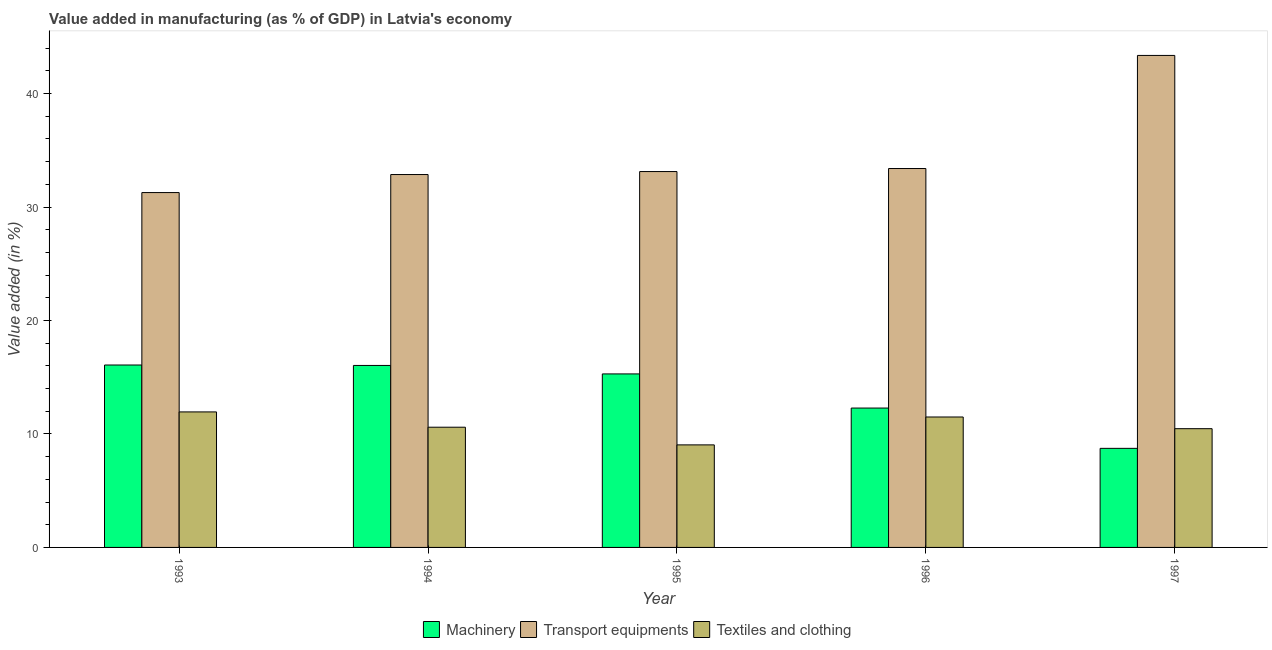How many different coloured bars are there?
Provide a short and direct response. 3. What is the value added in manufacturing textile and clothing in 1996?
Your answer should be compact. 11.5. Across all years, what is the maximum value added in manufacturing machinery?
Offer a terse response. 16.08. Across all years, what is the minimum value added in manufacturing textile and clothing?
Keep it short and to the point. 9.04. What is the total value added in manufacturing machinery in the graph?
Offer a very short reply. 68.42. What is the difference between the value added in manufacturing machinery in 1996 and that in 1997?
Offer a very short reply. 3.55. What is the difference between the value added in manufacturing transport equipments in 1997 and the value added in manufacturing machinery in 1994?
Keep it short and to the point. 10.5. What is the average value added in manufacturing textile and clothing per year?
Make the answer very short. 10.71. In the year 1993, what is the difference between the value added in manufacturing transport equipments and value added in manufacturing machinery?
Offer a very short reply. 0. What is the ratio of the value added in manufacturing transport equipments in 1994 to that in 1995?
Your answer should be very brief. 0.99. Is the difference between the value added in manufacturing machinery in 1995 and 1996 greater than the difference between the value added in manufacturing transport equipments in 1995 and 1996?
Make the answer very short. No. What is the difference between the highest and the second highest value added in manufacturing machinery?
Ensure brevity in your answer.  0.04. What is the difference between the highest and the lowest value added in manufacturing textile and clothing?
Provide a short and direct response. 2.91. In how many years, is the value added in manufacturing transport equipments greater than the average value added in manufacturing transport equipments taken over all years?
Your response must be concise. 1. Is the sum of the value added in manufacturing transport equipments in 1993 and 1994 greater than the maximum value added in manufacturing textile and clothing across all years?
Your answer should be very brief. Yes. What does the 3rd bar from the left in 1996 represents?
Ensure brevity in your answer.  Textiles and clothing. What does the 3rd bar from the right in 1993 represents?
Ensure brevity in your answer.  Machinery. Is it the case that in every year, the sum of the value added in manufacturing machinery and value added in manufacturing transport equipments is greater than the value added in manufacturing textile and clothing?
Make the answer very short. Yes. How many years are there in the graph?
Offer a very short reply. 5. Are the values on the major ticks of Y-axis written in scientific E-notation?
Make the answer very short. No. Does the graph contain any zero values?
Provide a short and direct response. No. Where does the legend appear in the graph?
Give a very brief answer. Bottom center. How are the legend labels stacked?
Ensure brevity in your answer.  Horizontal. What is the title of the graph?
Offer a very short reply. Value added in manufacturing (as % of GDP) in Latvia's economy. What is the label or title of the Y-axis?
Provide a succinct answer. Value added (in %). What is the Value added (in %) in Machinery in 1993?
Give a very brief answer. 16.08. What is the Value added (in %) in Transport equipments in 1993?
Ensure brevity in your answer.  31.28. What is the Value added (in %) in Textiles and clothing in 1993?
Your response must be concise. 11.94. What is the Value added (in %) of Machinery in 1994?
Your response must be concise. 16.04. What is the Value added (in %) of Transport equipments in 1994?
Keep it short and to the point. 32.86. What is the Value added (in %) of Textiles and clothing in 1994?
Your answer should be compact. 10.59. What is the Value added (in %) of Machinery in 1995?
Give a very brief answer. 15.29. What is the Value added (in %) in Transport equipments in 1995?
Your answer should be compact. 33.13. What is the Value added (in %) in Textiles and clothing in 1995?
Offer a very short reply. 9.04. What is the Value added (in %) in Machinery in 1996?
Provide a short and direct response. 12.28. What is the Value added (in %) in Transport equipments in 1996?
Provide a short and direct response. 33.39. What is the Value added (in %) of Textiles and clothing in 1996?
Your response must be concise. 11.5. What is the Value added (in %) in Machinery in 1997?
Make the answer very short. 8.73. What is the Value added (in %) in Transport equipments in 1997?
Keep it short and to the point. 43.36. What is the Value added (in %) of Textiles and clothing in 1997?
Make the answer very short. 10.47. Across all years, what is the maximum Value added (in %) in Machinery?
Provide a short and direct response. 16.08. Across all years, what is the maximum Value added (in %) in Transport equipments?
Your response must be concise. 43.36. Across all years, what is the maximum Value added (in %) of Textiles and clothing?
Your answer should be compact. 11.94. Across all years, what is the minimum Value added (in %) in Machinery?
Make the answer very short. 8.73. Across all years, what is the minimum Value added (in %) in Transport equipments?
Ensure brevity in your answer.  31.28. Across all years, what is the minimum Value added (in %) in Textiles and clothing?
Your response must be concise. 9.04. What is the total Value added (in %) in Machinery in the graph?
Offer a terse response. 68.42. What is the total Value added (in %) in Transport equipments in the graph?
Offer a very short reply. 174.02. What is the total Value added (in %) in Textiles and clothing in the graph?
Provide a short and direct response. 53.54. What is the difference between the Value added (in %) in Machinery in 1993 and that in 1994?
Make the answer very short. 0.04. What is the difference between the Value added (in %) in Transport equipments in 1993 and that in 1994?
Offer a very short reply. -1.59. What is the difference between the Value added (in %) in Textiles and clothing in 1993 and that in 1994?
Offer a terse response. 1.35. What is the difference between the Value added (in %) of Machinery in 1993 and that in 1995?
Provide a succinct answer. 0.78. What is the difference between the Value added (in %) in Transport equipments in 1993 and that in 1995?
Your answer should be compact. -1.85. What is the difference between the Value added (in %) of Textiles and clothing in 1993 and that in 1995?
Provide a succinct answer. 2.91. What is the difference between the Value added (in %) in Machinery in 1993 and that in 1996?
Offer a terse response. 3.79. What is the difference between the Value added (in %) in Transport equipments in 1993 and that in 1996?
Your answer should be very brief. -2.12. What is the difference between the Value added (in %) of Textiles and clothing in 1993 and that in 1996?
Offer a very short reply. 0.45. What is the difference between the Value added (in %) in Machinery in 1993 and that in 1997?
Provide a succinct answer. 7.34. What is the difference between the Value added (in %) of Transport equipments in 1993 and that in 1997?
Ensure brevity in your answer.  -12.09. What is the difference between the Value added (in %) in Textiles and clothing in 1993 and that in 1997?
Give a very brief answer. 1.48. What is the difference between the Value added (in %) of Machinery in 1994 and that in 1995?
Make the answer very short. 0.75. What is the difference between the Value added (in %) of Transport equipments in 1994 and that in 1995?
Keep it short and to the point. -0.26. What is the difference between the Value added (in %) of Textiles and clothing in 1994 and that in 1995?
Your response must be concise. 1.56. What is the difference between the Value added (in %) of Machinery in 1994 and that in 1996?
Your response must be concise. 3.76. What is the difference between the Value added (in %) in Transport equipments in 1994 and that in 1996?
Offer a very short reply. -0.53. What is the difference between the Value added (in %) in Textiles and clothing in 1994 and that in 1996?
Your answer should be compact. -0.9. What is the difference between the Value added (in %) of Machinery in 1994 and that in 1997?
Offer a terse response. 7.31. What is the difference between the Value added (in %) in Transport equipments in 1994 and that in 1997?
Make the answer very short. -10.5. What is the difference between the Value added (in %) in Textiles and clothing in 1994 and that in 1997?
Provide a short and direct response. 0.13. What is the difference between the Value added (in %) of Machinery in 1995 and that in 1996?
Give a very brief answer. 3.01. What is the difference between the Value added (in %) in Transport equipments in 1995 and that in 1996?
Ensure brevity in your answer.  -0.27. What is the difference between the Value added (in %) in Textiles and clothing in 1995 and that in 1996?
Provide a succinct answer. -2.46. What is the difference between the Value added (in %) of Machinery in 1995 and that in 1997?
Offer a very short reply. 6.56. What is the difference between the Value added (in %) of Transport equipments in 1995 and that in 1997?
Offer a very short reply. -10.23. What is the difference between the Value added (in %) in Textiles and clothing in 1995 and that in 1997?
Provide a succinct answer. -1.43. What is the difference between the Value added (in %) in Machinery in 1996 and that in 1997?
Your answer should be compact. 3.55. What is the difference between the Value added (in %) of Transport equipments in 1996 and that in 1997?
Make the answer very short. -9.97. What is the difference between the Value added (in %) in Textiles and clothing in 1996 and that in 1997?
Your answer should be very brief. 1.03. What is the difference between the Value added (in %) of Machinery in 1993 and the Value added (in %) of Transport equipments in 1994?
Your answer should be very brief. -16.79. What is the difference between the Value added (in %) of Machinery in 1993 and the Value added (in %) of Textiles and clothing in 1994?
Make the answer very short. 5.48. What is the difference between the Value added (in %) in Transport equipments in 1993 and the Value added (in %) in Textiles and clothing in 1994?
Your answer should be compact. 20.68. What is the difference between the Value added (in %) of Machinery in 1993 and the Value added (in %) of Transport equipments in 1995?
Provide a succinct answer. -17.05. What is the difference between the Value added (in %) in Machinery in 1993 and the Value added (in %) in Textiles and clothing in 1995?
Keep it short and to the point. 7.04. What is the difference between the Value added (in %) in Transport equipments in 1993 and the Value added (in %) in Textiles and clothing in 1995?
Make the answer very short. 22.24. What is the difference between the Value added (in %) of Machinery in 1993 and the Value added (in %) of Transport equipments in 1996?
Give a very brief answer. -17.32. What is the difference between the Value added (in %) in Machinery in 1993 and the Value added (in %) in Textiles and clothing in 1996?
Your answer should be compact. 4.58. What is the difference between the Value added (in %) in Transport equipments in 1993 and the Value added (in %) in Textiles and clothing in 1996?
Your answer should be very brief. 19.78. What is the difference between the Value added (in %) in Machinery in 1993 and the Value added (in %) in Transport equipments in 1997?
Your response must be concise. -27.29. What is the difference between the Value added (in %) in Machinery in 1993 and the Value added (in %) in Textiles and clothing in 1997?
Provide a short and direct response. 5.61. What is the difference between the Value added (in %) of Transport equipments in 1993 and the Value added (in %) of Textiles and clothing in 1997?
Give a very brief answer. 20.81. What is the difference between the Value added (in %) of Machinery in 1994 and the Value added (in %) of Transport equipments in 1995?
Your response must be concise. -17.09. What is the difference between the Value added (in %) in Machinery in 1994 and the Value added (in %) in Textiles and clothing in 1995?
Your response must be concise. 7. What is the difference between the Value added (in %) in Transport equipments in 1994 and the Value added (in %) in Textiles and clothing in 1995?
Provide a succinct answer. 23.83. What is the difference between the Value added (in %) in Machinery in 1994 and the Value added (in %) in Transport equipments in 1996?
Offer a very short reply. -17.36. What is the difference between the Value added (in %) in Machinery in 1994 and the Value added (in %) in Textiles and clothing in 1996?
Your response must be concise. 4.54. What is the difference between the Value added (in %) in Transport equipments in 1994 and the Value added (in %) in Textiles and clothing in 1996?
Your answer should be very brief. 21.37. What is the difference between the Value added (in %) of Machinery in 1994 and the Value added (in %) of Transport equipments in 1997?
Make the answer very short. -27.32. What is the difference between the Value added (in %) of Machinery in 1994 and the Value added (in %) of Textiles and clothing in 1997?
Offer a terse response. 5.57. What is the difference between the Value added (in %) of Transport equipments in 1994 and the Value added (in %) of Textiles and clothing in 1997?
Ensure brevity in your answer.  22.4. What is the difference between the Value added (in %) in Machinery in 1995 and the Value added (in %) in Transport equipments in 1996?
Keep it short and to the point. -18.1. What is the difference between the Value added (in %) of Machinery in 1995 and the Value added (in %) of Textiles and clothing in 1996?
Your answer should be compact. 3.8. What is the difference between the Value added (in %) in Transport equipments in 1995 and the Value added (in %) in Textiles and clothing in 1996?
Offer a very short reply. 21.63. What is the difference between the Value added (in %) of Machinery in 1995 and the Value added (in %) of Transport equipments in 1997?
Ensure brevity in your answer.  -28.07. What is the difference between the Value added (in %) of Machinery in 1995 and the Value added (in %) of Textiles and clothing in 1997?
Keep it short and to the point. 4.83. What is the difference between the Value added (in %) of Transport equipments in 1995 and the Value added (in %) of Textiles and clothing in 1997?
Ensure brevity in your answer.  22.66. What is the difference between the Value added (in %) in Machinery in 1996 and the Value added (in %) in Transport equipments in 1997?
Ensure brevity in your answer.  -31.08. What is the difference between the Value added (in %) of Machinery in 1996 and the Value added (in %) of Textiles and clothing in 1997?
Your answer should be very brief. 1.82. What is the difference between the Value added (in %) in Transport equipments in 1996 and the Value added (in %) in Textiles and clothing in 1997?
Provide a short and direct response. 22.93. What is the average Value added (in %) in Machinery per year?
Provide a succinct answer. 13.68. What is the average Value added (in %) in Transport equipments per year?
Ensure brevity in your answer.  34.8. What is the average Value added (in %) of Textiles and clothing per year?
Offer a very short reply. 10.71. In the year 1993, what is the difference between the Value added (in %) in Machinery and Value added (in %) in Transport equipments?
Make the answer very short. -15.2. In the year 1993, what is the difference between the Value added (in %) in Machinery and Value added (in %) in Textiles and clothing?
Give a very brief answer. 4.13. In the year 1993, what is the difference between the Value added (in %) of Transport equipments and Value added (in %) of Textiles and clothing?
Keep it short and to the point. 19.33. In the year 1994, what is the difference between the Value added (in %) in Machinery and Value added (in %) in Transport equipments?
Provide a short and direct response. -16.83. In the year 1994, what is the difference between the Value added (in %) in Machinery and Value added (in %) in Textiles and clothing?
Offer a very short reply. 5.44. In the year 1994, what is the difference between the Value added (in %) in Transport equipments and Value added (in %) in Textiles and clothing?
Your answer should be compact. 22.27. In the year 1995, what is the difference between the Value added (in %) of Machinery and Value added (in %) of Transport equipments?
Your response must be concise. -17.84. In the year 1995, what is the difference between the Value added (in %) of Machinery and Value added (in %) of Textiles and clothing?
Your response must be concise. 6.25. In the year 1995, what is the difference between the Value added (in %) of Transport equipments and Value added (in %) of Textiles and clothing?
Provide a short and direct response. 24.09. In the year 1996, what is the difference between the Value added (in %) of Machinery and Value added (in %) of Transport equipments?
Your response must be concise. -21.11. In the year 1996, what is the difference between the Value added (in %) of Machinery and Value added (in %) of Textiles and clothing?
Make the answer very short. 0.79. In the year 1996, what is the difference between the Value added (in %) in Transport equipments and Value added (in %) in Textiles and clothing?
Offer a terse response. 21.9. In the year 1997, what is the difference between the Value added (in %) of Machinery and Value added (in %) of Transport equipments?
Offer a terse response. -34.63. In the year 1997, what is the difference between the Value added (in %) in Machinery and Value added (in %) in Textiles and clothing?
Provide a succinct answer. -1.73. In the year 1997, what is the difference between the Value added (in %) of Transport equipments and Value added (in %) of Textiles and clothing?
Give a very brief answer. 32.9. What is the ratio of the Value added (in %) of Transport equipments in 1993 to that in 1994?
Offer a very short reply. 0.95. What is the ratio of the Value added (in %) of Textiles and clothing in 1993 to that in 1994?
Provide a succinct answer. 1.13. What is the ratio of the Value added (in %) of Machinery in 1993 to that in 1995?
Offer a terse response. 1.05. What is the ratio of the Value added (in %) of Transport equipments in 1993 to that in 1995?
Ensure brevity in your answer.  0.94. What is the ratio of the Value added (in %) in Textiles and clothing in 1993 to that in 1995?
Your answer should be compact. 1.32. What is the ratio of the Value added (in %) of Machinery in 1993 to that in 1996?
Provide a succinct answer. 1.31. What is the ratio of the Value added (in %) of Transport equipments in 1993 to that in 1996?
Your response must be concise. 0.94. What is the ratio of the Value added (in %) in Textiles and clothing in 1993 to that in 1996?
Your answer should be compact. 1.04. What is the ratio of the Value added (in %) in Machinery in 1993 to that in 1997?
Ensure brevity in your answer.  1.84. What is the ratio of the Value added (in %) of Transport equipments in 1993 to that in 1997?
Your answer should be very brief. 0.72. What is the ratio of the Value added (in %) of Textiles and clothing in 1993 to that in 1997?
Make the answer very short. 1.14. What is the ratio of the Value added (in %) in Machinery in 1994 to that in 1995?
Offer a terse response. 1.05. What is the ratio of the Value added (in %) of Textiles and clothing in 1994 to that in 1995?
Provide a short and direct response. 1.17. What is the ratio of the Value added (in %) in Machinery in 1994 to that in 1996?
Your response must be concise. 1.31. What is the ratio of the Value added (in %) of Transport equipments in 1994 to that in 1996?
Provide a succinct answer. 0.98. What is the ratio of the Value added (in %) of Textiles and clothing in 1994 to that in 1996?
Offer a very short reply. 0.92. What is the ratio of the Value added (in %) of Machinery in 1994 to that in 1997?
Your answer should be compact. 1.84. What is the ratio of the Value added (in %) of Transport equipments in 1994 to that in 1997?
Offer a terse response. 0.76. What is the ratio of the Value added (in %) in Textiles and clothing in 1994 to that in 1997?
Give a very brief answer. 1.01. What is the ratio of the Value added (in %) of Machinery in 1995 to that in 1996?
Offer a terse response. 1.25. What is the ratio of the Value added (in %) of Transport equipments in 1995 to that in 1996?
Your response must be concise. 0.99. What is the ratio of the Value added (in %) of Textiles and clothing in 1995 to that in 1996?
Provide a short and direct response. 0.79. What is the ratio of the Value added (in %) in Machinery in 1995 to that in 1997?
Your answer should be very brief. 1.75. What is the ratio of the Value added (in %) of Transport equipments in 1995 to that in 1997?
Provide a short and direct response. 0.76. What is the ratio of the Value added (in %) of Textiles and clothing in 1995 to that in 1997?
Your answer should be very brief. 0.86. What is the ratio of the Value added (in %) of Machinery in 1996 to that in 1997?
Your answer should be compact. 1.41. What is the ratio of the Value added (in %) in Transport equipments in 1996 to that in 1997?
Offer a terse response. 0.77. What is the ratio of the Value added (in %) in Textiles and clothing in 1996 to that in 1997?
Your answer should be very brief. 1.1. What is the difference between the highest and the second highest Value added (in %) in Machinery?
Your response must be concise. 0.04. What is the difference between the highest and the second highest Value added (in %) of Transport equipments?
Your response must be concise. 9.97. What is the difference between the highest and the second highest Value added (in %) in Textiles and clothing?
Your response must be concise. 0.45. What is the difference between the highest and the lowest Value added (in %) in Machinery?
Provide a succinct answer. 7.34. What is the difference between the highest and the lowest Value added (in %) of Transport equipments?
Provide a short and direct response. 12.09. What is the difference between the highest and the lowest Value added (in %) in Textiles and clothing?
Your response must be concise. 2.91. 